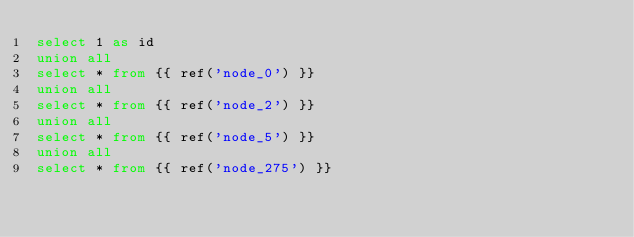Convert code to text. <code><loc_0><loc_0><loc_500><loc_500><_SQL_>select 1 as id
union all
select * from {{ ref('node_0') }}
union all
select * from {{ ref('node_2') }}
union all
select * from {{ ref('node_5') }}
union all
select * from {{ ref('node_275') }}
</code> 